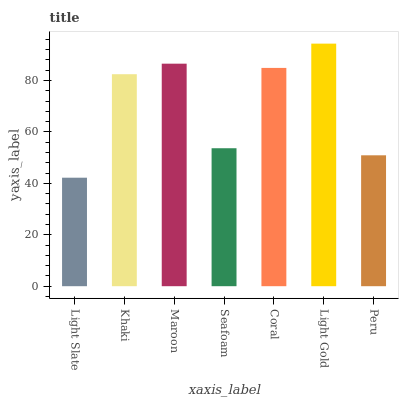Is Light Slate the minimum?
Answer yes or no. Yes. Is Light Gold the maximum?
Answer yes or no. Yes. Is Khaki the minimum?
Answer yes or no. No. Is Khaki the maximum?
Answer yes or no. No. Is Khaki greater than Light Slate?
Answer yes or no. Yes. Is Light Slate less than Khaki?
Answer yes or no. Yes. Is Light Slate greater than Khaki?
Answer yes or no. No. Is Khaki less than Light Slate?
Answer yes or no. No. Is Khaki the high median?
Answer yes or no. Yes. Is Khaki the low median?
Answer yes or no. Yes. Is Seafoam the high median?
Answer yes or no. No. Is Light Gold the low median?
Answer yes or no. No. 